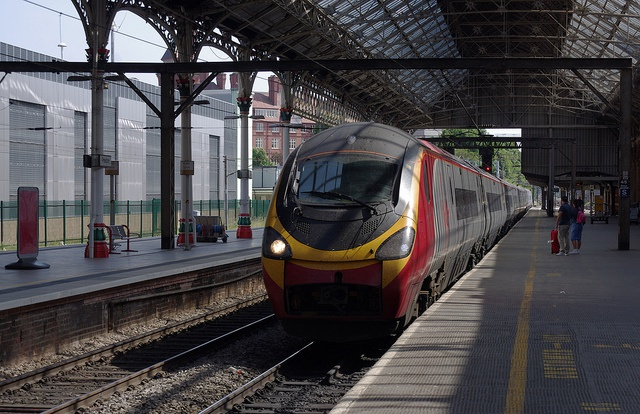Describe the objects in this image and their specific colors. I can see train in lavender, black, gray, and maroon tones, people in lavender, black, gray, and maroon tones, people in lavender, black, navy, purple, and gray tones, bench in lavender, black, gray, and darkblue tones, and traffic light in lavender, black, maroon, and salmon tones in this image. 